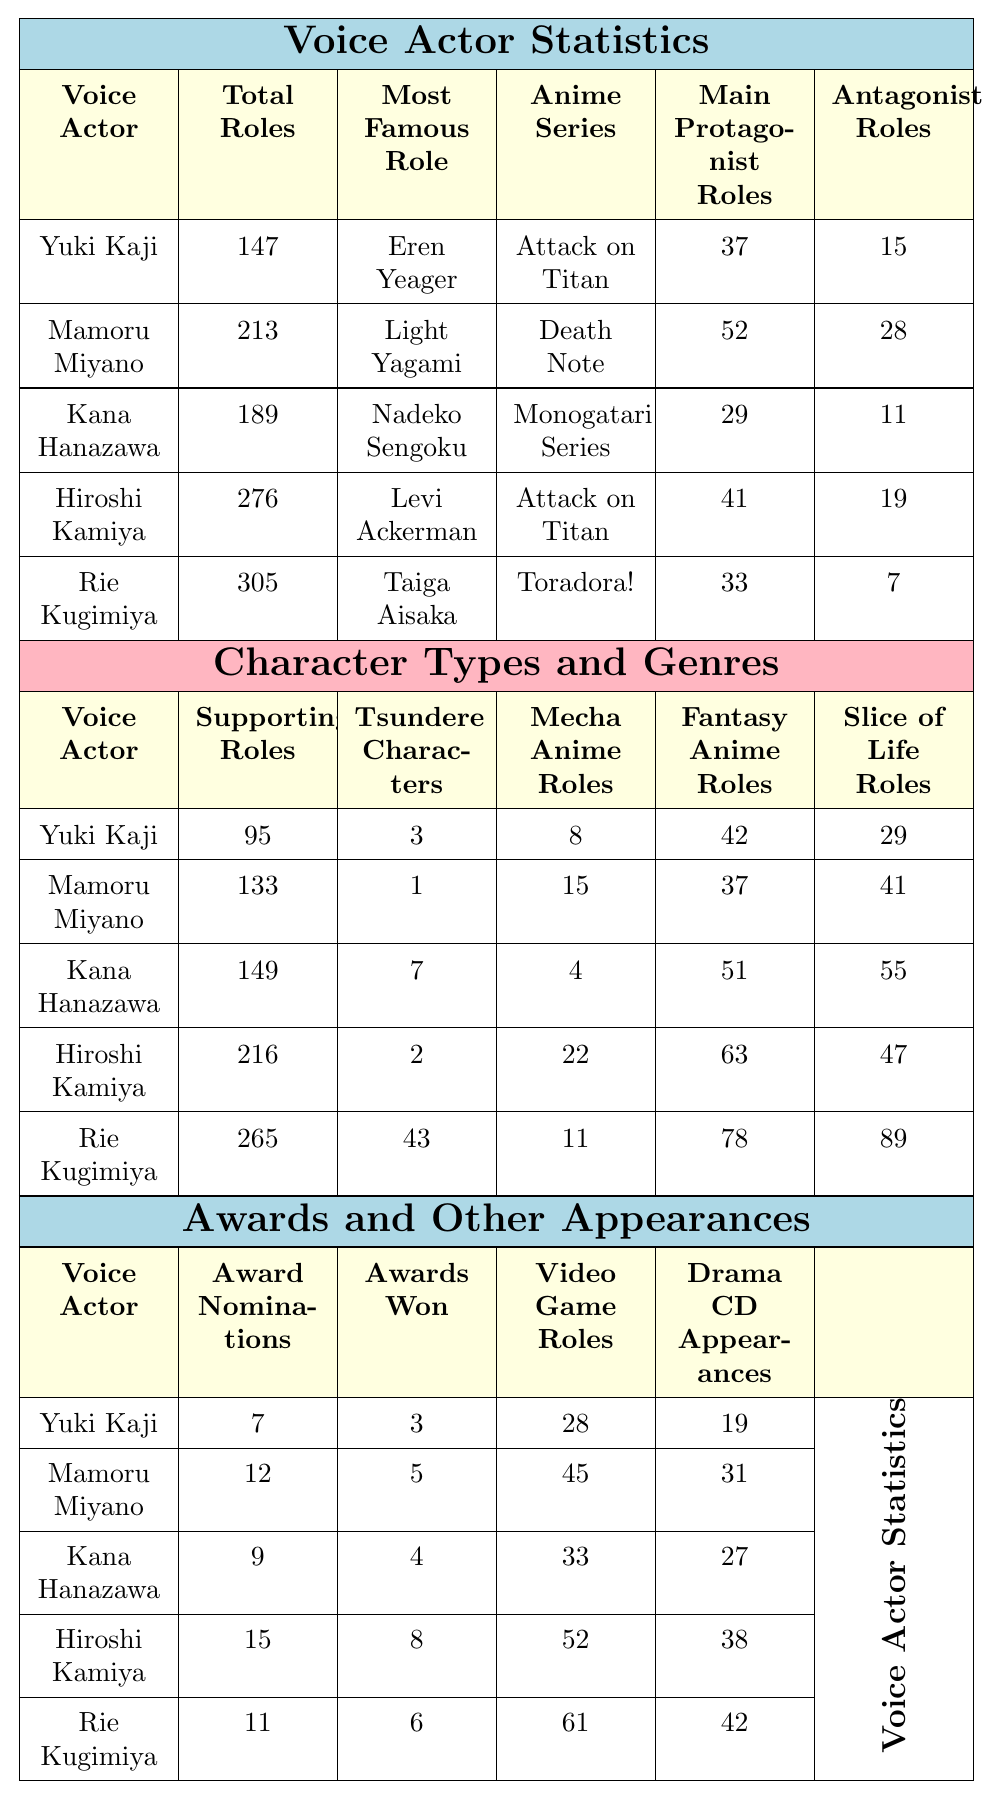What is the total number of roles for Rie Kugimiya? The table lists Rie Kugimiya's total roles as 305.
Answer: 305 Who has the most awards won among the voice actors? Comparing the awards won, Hiroshi Kamiya has 8 awards, which is the highest among the listed voice actors.
Answer: Hiroshi Kamiya How many tsundere characters has Kana Hanazawa voiced? According to the table, Kana Hanazawa has voiced 7 tsundere characters.
Answer: 7 What is the total number of protagonist roles for all voice actors combined? Summing the main protagonist roles: 37 + 52 + 29 + 41 + 33 = 192.
Answer: 192 Which voice actor has the least antagonist roles? Rie Kugimiya has the least antagonist roles with only 7 roles.
Answer: Rie Kugimiya What percentage of total roles for Mamoru Miyano are main protagonist roles? Mamoru Miyano has 52 main protagonist roles out of a total of 213. The percentage is (52/213) * 100 ≈ 24.4%.
Answer: 24.4% Is there any voice actor who has voiced more than 250 supporting character roles? Yes, Hiroshi Kamiya and Rie Kugimiya have voiced more than 250 supporting character roles with counts of 216 and 265, respectively.
Answer: Yes Which character type has the highest count for Yuki Kaji? Yuki Kaji has the highest count of supporting character roles, totaling 95.
Answer: Supporting character roles What is the average number of video game roles across all listed voice actors? The total video game roles are calculated as 28 + 45 + 33 + 52 + 61 = 219. Dividing this by 5 gives an average of 219/5 = 43.8.
Answer: 43.8 Who has the most significant difference between supporting character roles and antagonist roles? Rie Kugimiya has 265 supporting character roles and 7 antagonist roles, giving a difference of 265 - 7 = 258, which is the largest.
Answer: Rie Kugimiya 